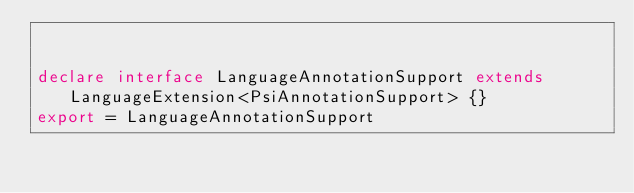<code> <loc_0><loc_0><loc_500><loc_500><_TypeScript_>

declare interface LanguageAnnotationSupport extends LanguageExtension<PsiAnnotationSupport> {}
export = LanguageAnnotationSupport
</code> 